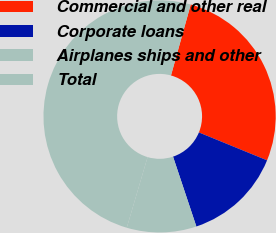Convert chart to OTSL. <chart><loc_0><loc_0><loc_500><loc_500><pie_chart><fcel>Commercial and other real<fcel>Corporate loans<fcel>Airplanes ships and other<fcel>Total<nl><fcel>26.86%<fcel>13.69%<fcel>9.69%<fcel>49.76%<nl></chart> 